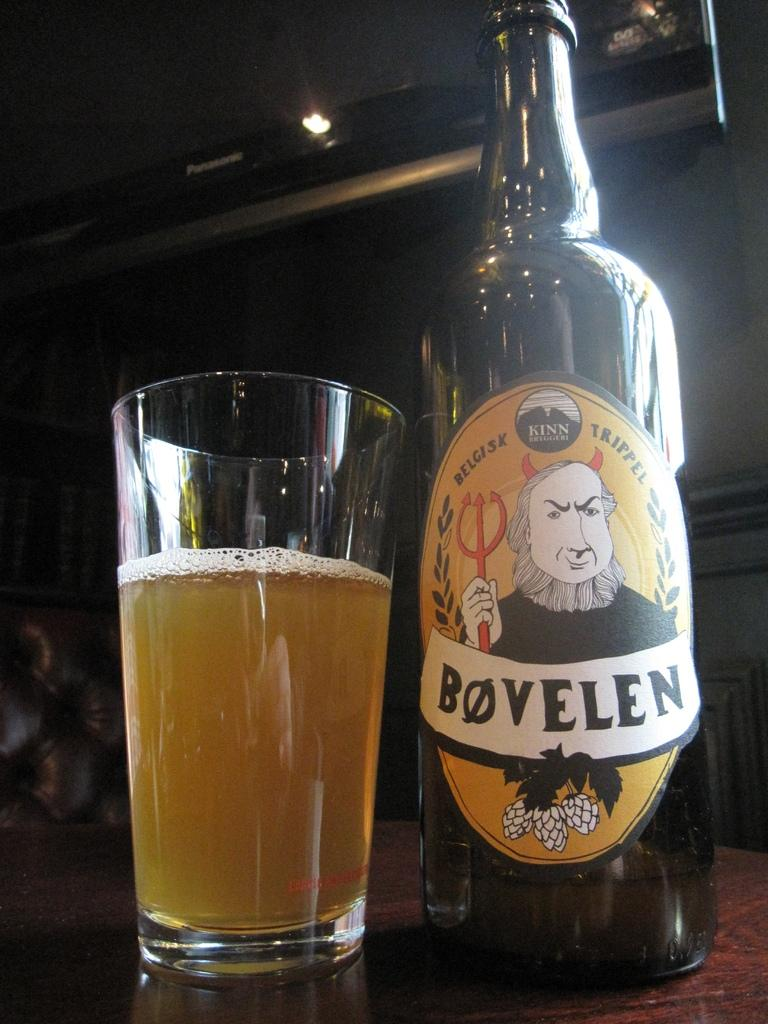Provide a one-sentence caption for the provided image. A bottle for Bovelen ale sits next to a pint glass. 